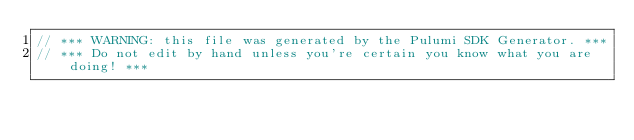Convert code to text. <code><loc_0><loc_0><loc_500><loc_500><_C#_>// *** WARNING: this file was generated by the Pulumi SDK Generator. ***
// *** Do not edit by hand unless you're certain you know what you are doing! ***
</code> 